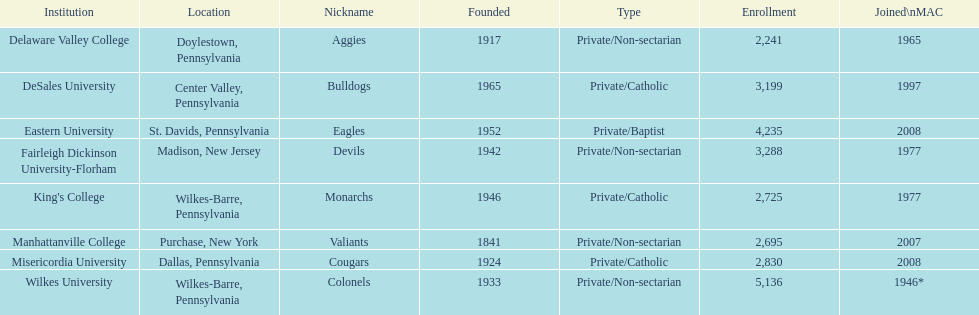List the establishments with a student population exceeding 4,00 Eastern University, Wilkes University. 